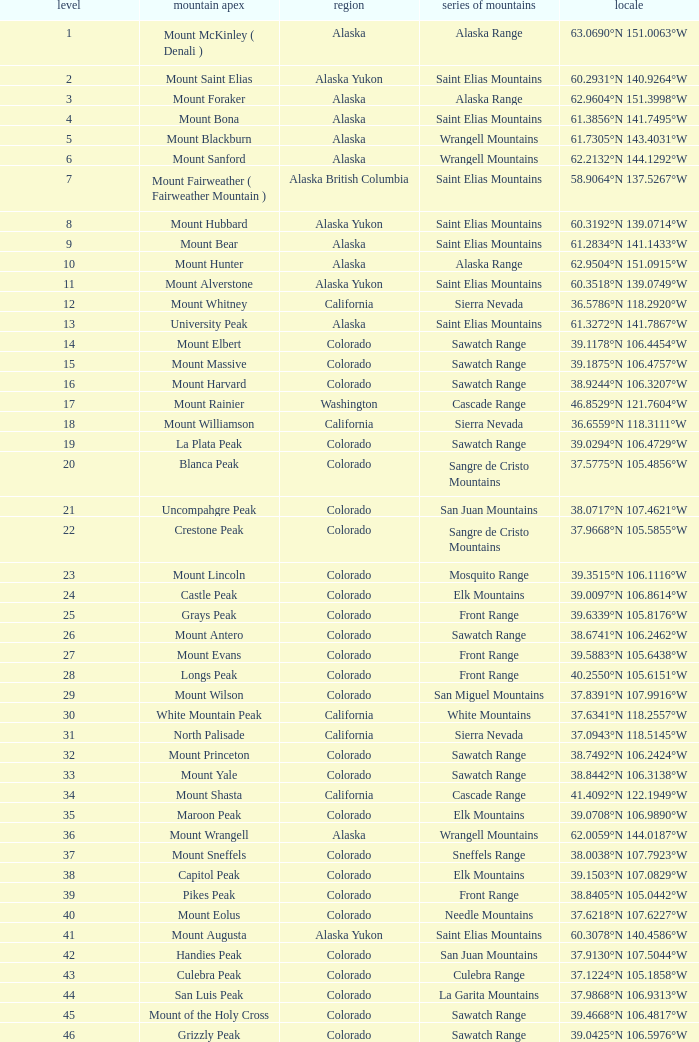What is the rank when the state is colorado and the location is 37.7859°n 107.7039°w? 83.0. 